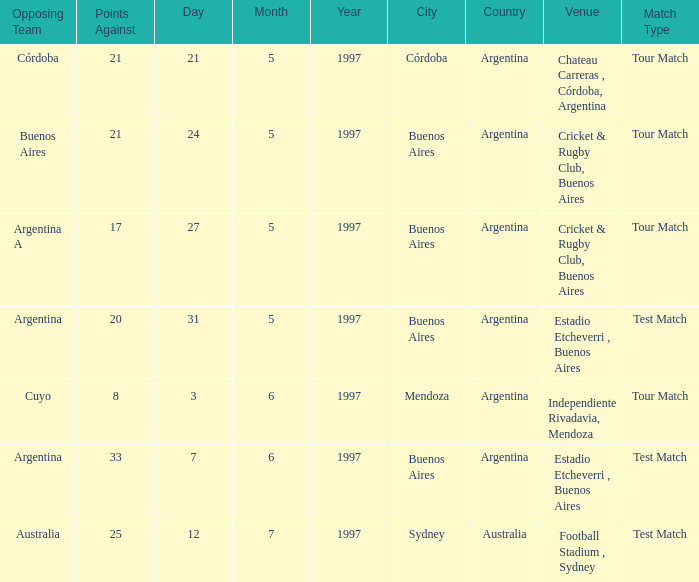What was the average of againsts on 21/5/1997? 21.0. 